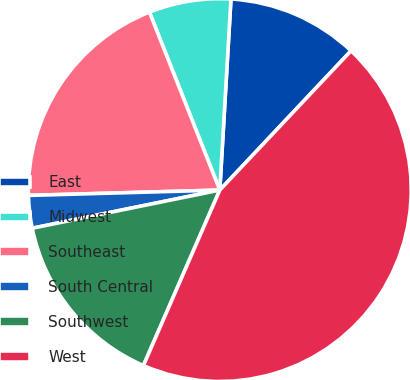Convert chart to OTSL. <chart><loc_0><loc_0><loc_500><loc_500><pie_chart><fcel>East<fcel>Midwest<fcel>Southeast<fcel>South Central<fcel>Southwest<fcel>West<nl><fcel>11.1%<fcel>6.92%<fcel>19.45%<fcel>2.75%<fcel>15.27%<fcel>44.5%<nl></chart> 